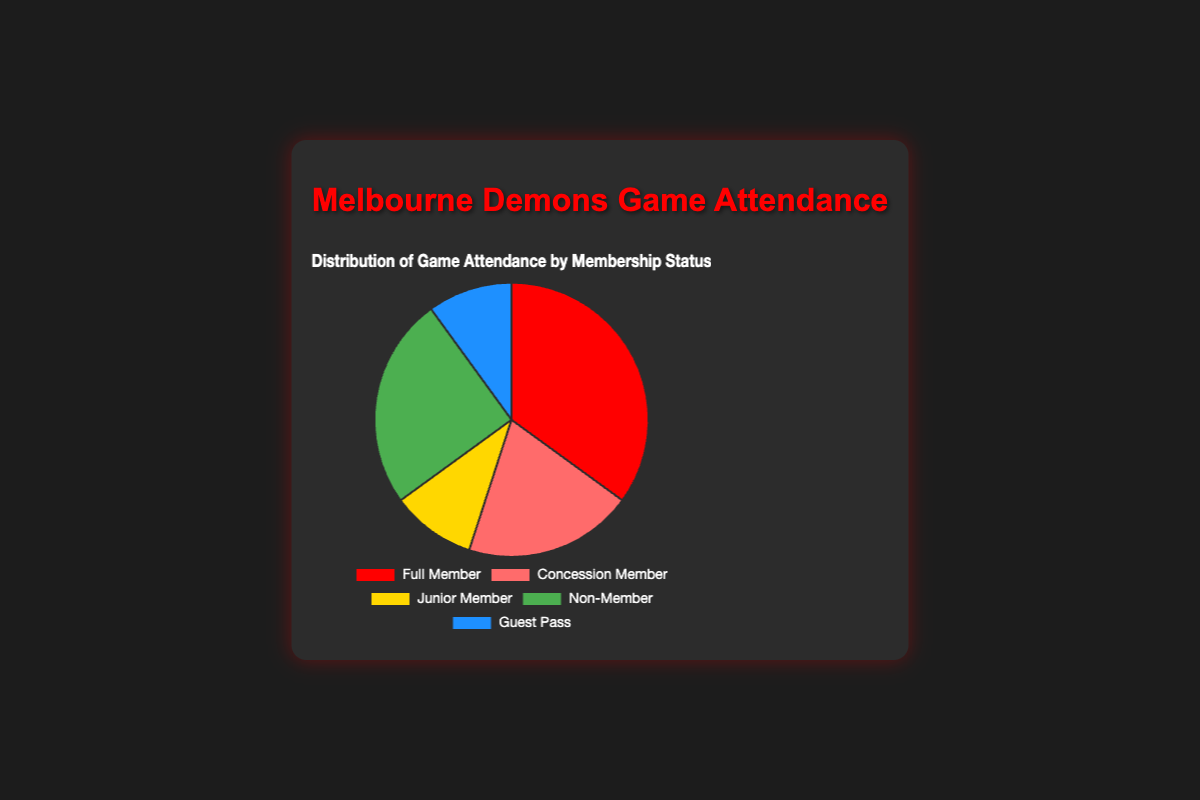what percentage of attendees are full members? The segment labeled "Full Member" shows 35%, so attendees who are full members make up 35% of the total
Answer: 35% Which membership status has the smallest percentage of game attendance? The segments labeled "Junior Member" and "Guest Pass" both show 10%, which are the smallest percentages among all categories
Answer: Junior Member or Guest Pass How much more game attendance is there from full members compared to junior members? Full members have a 35% attendance rate, while junior members have a 10% attendance rate. The difference is 35% - 10% = 25%
Answer: 25% Combine the percentages of concession members and non-members. What's the sum? Concession members have 20% attendance and non-members have 25%, so the combined percentage is 20% + 25% = 45%
Answer: 45% Which category has greater attendance: concession members or guest pass holders? The concession members have 20% attendance, whereas guest pass holders have 10% attendance. Therefore, concession members have greater attendance
Answer: Concession Member What percentage of game attendees are either non-members or full members? Non-members have 25% and full members have 35%, so combined it's 25% + 35% = 60%
Answer: 60% Compare the percentages of junior members and guest pass holders. Are they equal? Both junior members and guest pass holders have a 10% attendance rate. Therefore, their percentages are equal
Answer: Yes If you were to combine the junior members and guest pass holders, what would their total percentage be? Both the junior members and guest pass holders each have a 10% attendance rate. Combined, they make 10% + 10% = 20%
Answer: 20% Identify the category with the highest percentage of game attendance. The segment representing full members displays the highest percentage of game attendance at 35%
Answer: Full Member Calculate the average percentage of attendance across all membership statuses. The data points are 35%, 20%, 10%, 25%, and 10%. Sum them up to get 35 + 20 + 10 + 25 + 10 = 100. Divide by 5 (the number of categories), giving 100 / 5 = 20%
Answer: 20% 